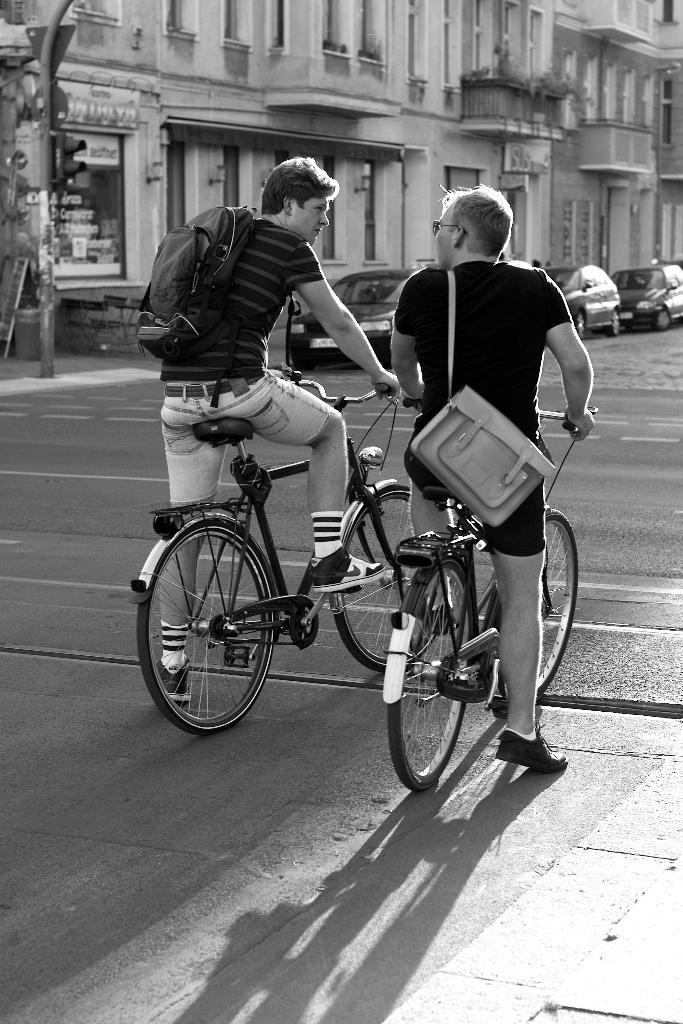How many people are in the image? There are two men in the image. What are the men doing in the image? The men are standing with bicycles. What are the men wearing that might be used for carrying items? The men are wearing bags. What type of pathway is visible in the image? There is a road in the image. What can be seen in the distance behind the men? There are cars in the background of the image. What flavor of ice cream is being served from the tank in the image? There is no ice cream or tank present in the image. 